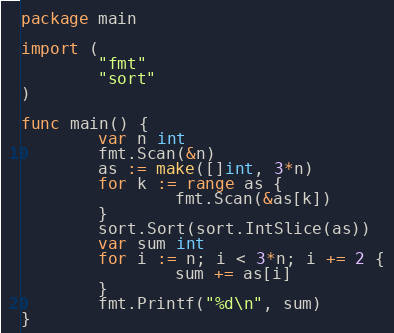<code> <loc_0><loc_0><loc_500><loc_500><_Go_>package main

import (
        "fmt"
        "sort"
)

func main() {
        var n int
        fmt.Scan(&n)
        as := make([]int, 3*n)
        for k := range as {
                fmt.Scan(&as[k])
        }
        sort.Sort(sort.IntSlice(as))
        var sum int
        for i := n; i < 3*n; i += 2 {
                sum += as[i]
        }
        fmt.Printf("%d\n", sum)
}</code> 